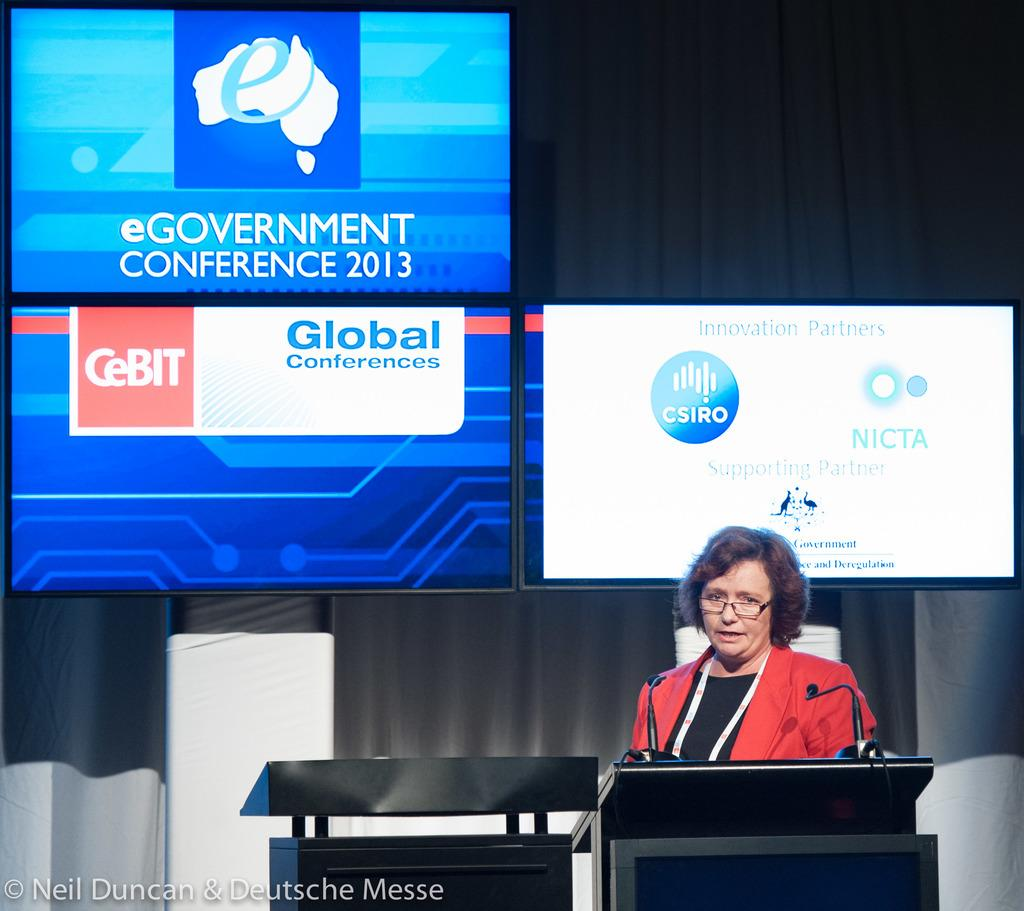<image>
Give a short and clear explanation of the subsequent image. A woman in glasses gives a speech at the eGovernment Conference 2013. 